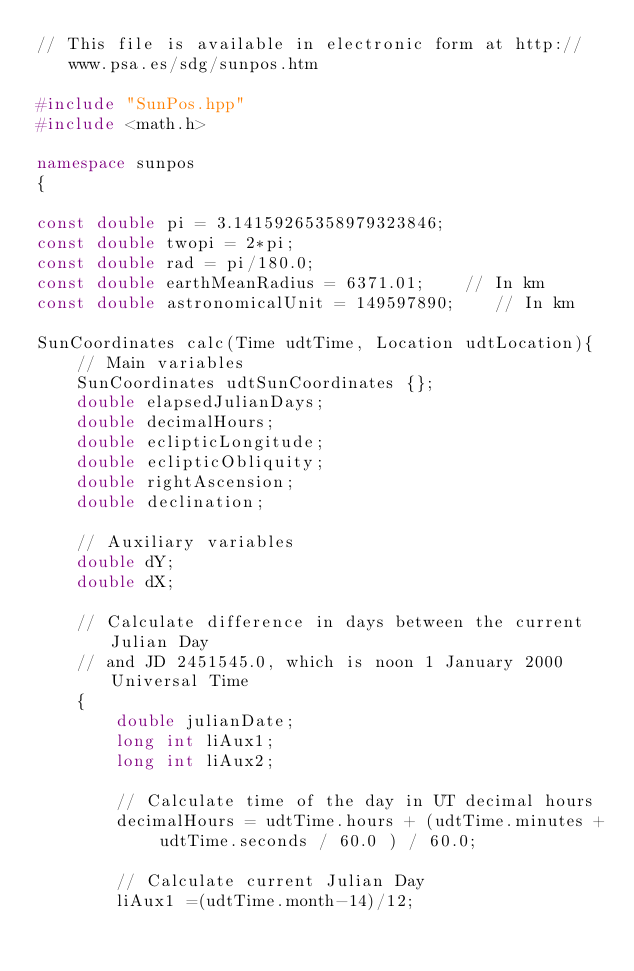<code> <loc_0><loc_0><loc_500><loc_500><_C++_>// This file is available in electronic form at http://www.psa.es/sdg/sunpos.htm

#include "SunPos.hpp"
#include <math.h>

namespace sunpos
{

const double pi = 3.14159265358979323846;
const double twopi = 2*pi;
const double rad = pi/180.0;
const double earthMeanRadius = 6371.01;    // In km
const double astronomicalUnit = 149597890;    // In km

SunCoordinates calc(Time udtTime, Location udtLocation){
    // Main variables
    SunCoordinates udtSunCoordinates {};
    double elapsedJulianDays;
    double decimalHours;
    double eclipticLongitude;
    double eclipticObliquity;
    double rightAscension;
    double declination;

    // Auxiliary variables
    double dY;
    double dX;

    // Calculate difference in days between the current Julian Day
    // and JD 2451545.0, which is noon 1 January 2000 Universal Time
    {
        double julianDate;
        long int liAux1;
        long int liAux2;

        // Calculate time of the day in UT decimal hours
        decimalHours = udtTime.hours + (udtTime.minutes + udtTime.seconds / 60.0 ) / 60.0;

        // Calculate current Julian Day
        liAux1 =(udtTime.month-14)/12;</code> 